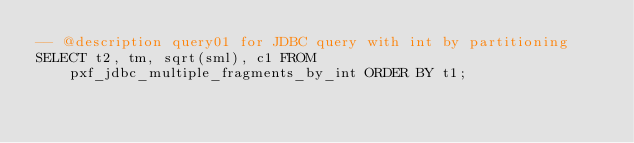Convert code to text. <code><loc_0><loc_0><loc_500><loc_500><_SQL_>-- @description query01 for JDBC query with int by partitioning
SELECT t2, tm, sqrt(sml), c1 FROM pxf_jdbc_multiple_fragments_by_int ORDER BY t1;
</code> 